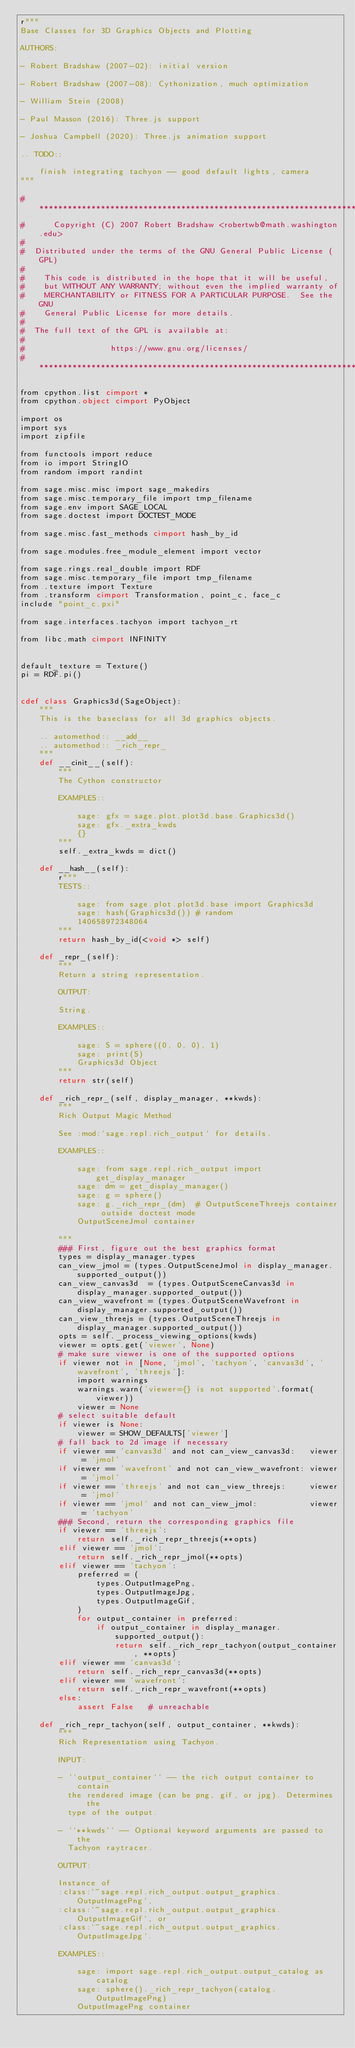Convert code to text. <code><loc_0><loc_0><loc_500><loc_500><_Cython_>r"""
Base Classes for 3D Graphics Objects and Plotting

AUTHORS:

- Robert Bradshaw (2007-02): initial version

- Robert Bradshaw (2007-08): Cythonization, much optimization

- William Stein (2008)

- Paul Masson (2016): Three.js support

- Joshua Campbell (2020): Three.js animation support

.. TODO::

    finish integrating tachyon -- good default lights, camera
"""

# ****************************************************************************
#      Copyright (C) 2007 Robert Bradshaw <robertwb@math.washington.edu>
#
#  Distributed under the terms of the GNU General Public License (GPL)
#
#    This code is distributed in the hope that it will be useful,
#    but WITHOUT ANY WARRANTY; without even the implied warranty of
#    MERCHANTABILITY or FITNESS FOR A PARTICULAR PURPOSE.  See the GNU
#    General Public License for more details.
#
#  The full text of the GPL is available at:
#
#                  https://www.gnu.org/licenses/
# ****************************************************************************

from cpython.list cimport *
from cpython.object cimport PyObject

import os
import sys
import zipfile

from functools import reduce
from io import StringIO
from random import randint

from sage.misc.misc import sage_makedirs
from sage.misc.temporary_file import tmp_filename
from sage.env import SAGE_LOCAL
from sage.doctest import DOCTEST_MODE

from sage.misc.fast_methods cimport hash_by_id

from sage.modules.free_module_element import vector

from sage.rings.real_double import RDF
from sage.misc.temporary_file import tmp_filename
from .texture import Texture
from .transform cimport Transformation, point_c, face_c
include "point_c.pxi"

from sage.interfaces.tachyon import tachyon_rt

from libc.math cimport INFINITY


default_texture = Texture()
pi = RDF.pi()


cdef class Graphics3d(SageObject):
    """
    This is the baseclass for all 3d graphics objects.

    .. automethod:: __add__
    .. automethod:: _rich_repr_
    """
    def __cinit__(self):
        """
        The Cython constructor

        EXAMPLES::

            sage: gfx = sage.plot.plot3d.base.Graphics3d()
            sage: gfx._extra_kwds
            {}
        """
        self._extra_kwds = dict()

    def __hash__(self):
        r"""
        TESTS::

            sage: from sage.plot.plot3d.base import Graphics3d
            sage: hash(Graphics3d()) # random
            140658972348064
        """
        return hash_by_id(<void *> self)

    def _repr_(self):
        """
        Return a string representation.

        OUTPUT:

        String.

        EXAMPLES::

            sage: S = sphere((0, 0, 0), 1)
            sage: print(S)
            Graphics3d Object
        """
        return str(self)

    def _rich_repr_(self, display_manager, **kwds):
        """
        Rich Output Magic Method

        See :mod:`sage.repl.rich_output` for details.

        EXAMPLES::

            sage: from sage.repl.rich_output import get_display_manager
            sage: dm = get_display_manager()
            sage: g = sphere()
            sage: g._rich_repr_(dm)  # OutputSceneThreejs container outside doctest mode
            OutputSceneJmol container

        """
        ### First, figure out the best graphics format
        types = display_manager.types
        can_view_jmol = (types.OutputSceneJmol in display_manager.supported_output())
        can_view_canvas3d  = (types.OutputSceneCanvas3d in display_manager.supported_output())
        can_view_wavefront = (types.OutputSceneWavefront in display_manager.supported_output())
        can_view_threejs = (types.OutputSceneThreejs in display_manager.supported_output())
        opts = self._process_viewing_options(kwds)
        viewer = opts.get('viewer', None)
        # make sure viewer is one of the supported options
        if viewer not in [None, 'jmol', 'tachyon', 'canvas3d', 'wavefront', 'threejs']:
            import warnings
            warnings.warn('viewer={} is not supported'.format(viewer))
            viewer = None
        # select suitable default
        if viewer is None:
            viewer = SHOW_DEFAULTS['viewer']
        # fall back to 2d image if necessary
        if viewer == 'canvas3d' and not can_view_canvas3d:   viewer = 'jmol'
        if viewer == 'wavefront' and not can_view_wavefront: viewer = 'jmol'
        if viewer == 'threejs' and not can_view_threejs:     viewer = 'jmol'
        if viewer == 'jmol' and not can_view_jmol:           viewer = 'tachyon'
        ### Second, return the corresponding graphics file
        if viewer == 'threejs':
            return self._rich_repr_threejs(**opts)
        elif viewer == 'jmol':
            return self._rich_repr_jmol(**opts)
        elif viewer == 'tachyon':
            preferred = (
                types.OutputImagePng,
                types.OutputImageJpg,
                types.OutputImageGif,
            )
            for output_container in preferred:
                if output_container in display_manager.supported_output():
                    return self._rich_repr_tachyon(output_container, **opts)
        elif viewer == 'canvas3d':
            return self._rich_repr_canvas3d(**opts)
        elif viewer == 'wavefront':
            return self._rich_repr_wavefront(**opts)
        else:
            assert False   # unreachable

    def _rich_repr_tachyon(self, output_container, **kwds):
        """
        Rich Representation using Tachyon.

        INPUT:

        - ``output_container`` -- the rich output container to contain
          the rendered image (can be png, gif, or jpg). Determines the
          type of the output.

        - ``**kwds`` -- Optional keyword arguments are passed to the
          Tachyon raytracer.

        OUTPUT:

        Instance of
        :class:`~sage.repl.rich_output.output_graphics.OutputImagePng`,
        :class:`~sage.repl.rich_output.output_graphics.OutputImageGif`, or
        :class:`~sage.repl.rich_output.output_graphics.OutputImageJpg`.

        EXAMPLES::

            sage: import sage.repl.rich_output.output_catalog as catalog
            sage: sphere()._rich_repr_tachyon(catalog.OutputImagePng)
            OutputImagePng container</code> 